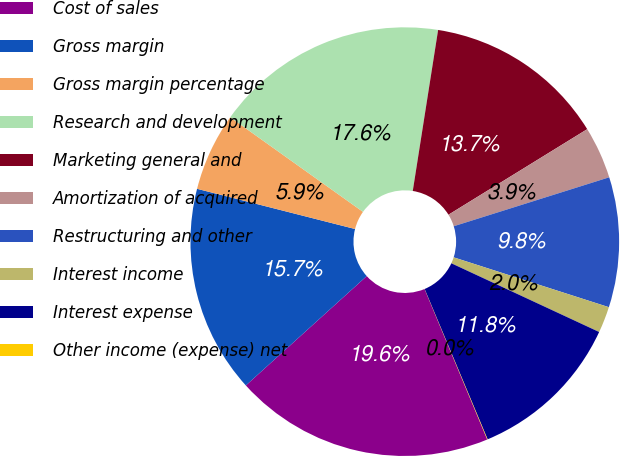<chart> <loc_0><loc_0><loc_500><loc_500><pie_chart><fcel>Cost of sales<fcel>Gross margin<fcel>Gross margin percentage<fcel>Research and development<fcel>Marketing general and<fcel>Amortization of acquired<fcel>Restructuring and other<fcel>Interest income<fcel>Interest expense<fcel>Other income (expense) net<nl><fcel>19.58%<fcel>15.67%<fcel>5.89%<fcel>17.63%<fcel>13.72%<fcel>3.94%<fcel>9.8%<fcel>1.98%<fcel>11.76%<fcel>0.03%<nl></chart> 